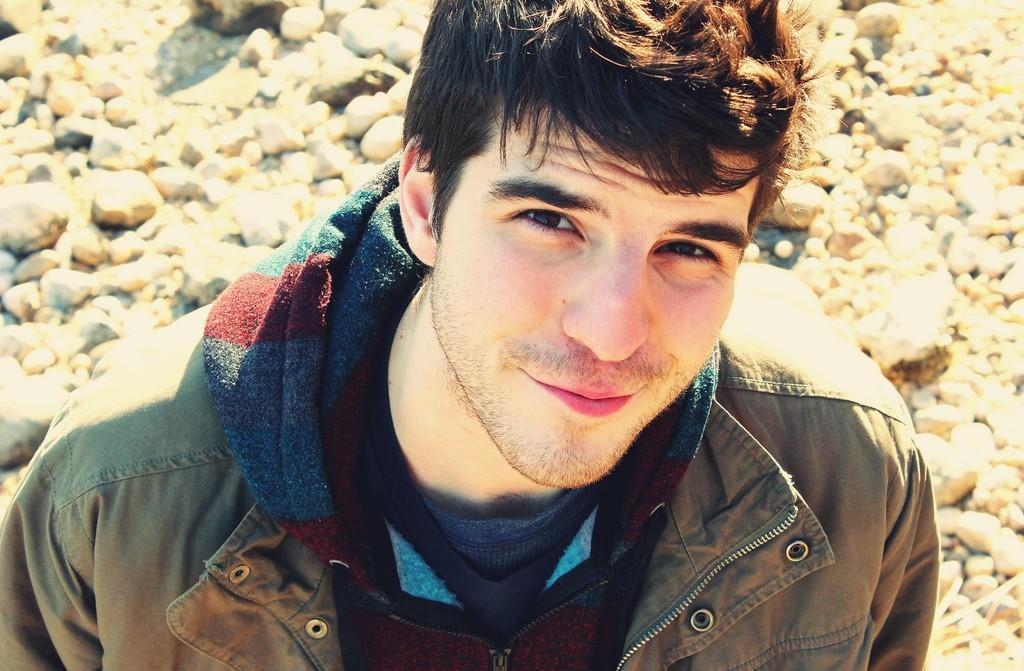Please provide a concise description of this image. In the picture I can see a man is standing on the ground and smiling. The man is wearing a jacket. In the background I can see stones on the ground. 